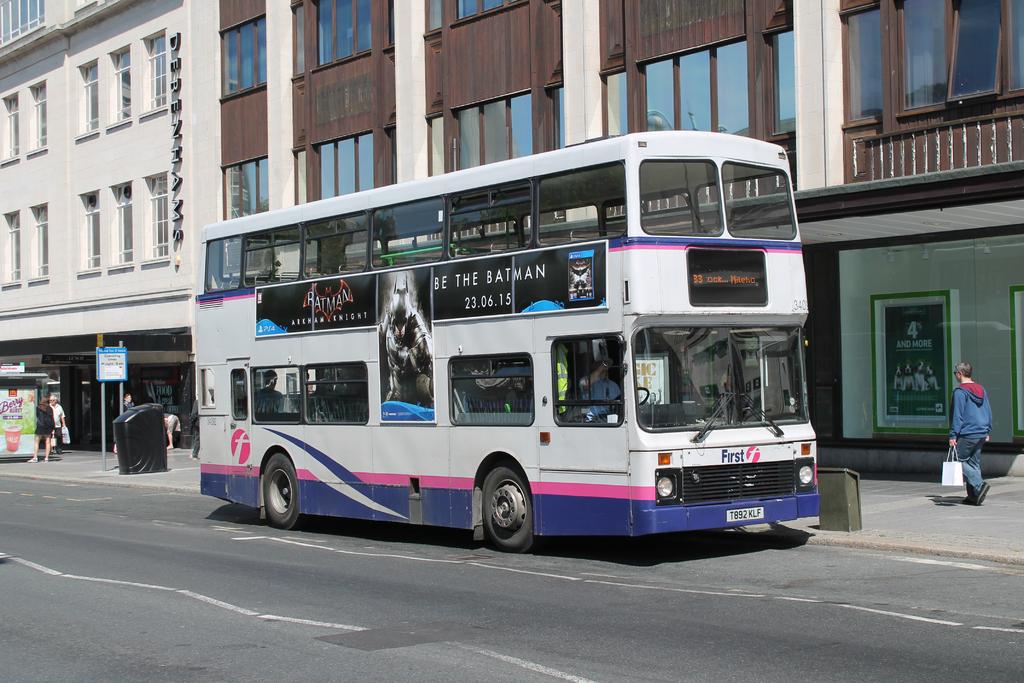What does the front of this bus say?
Offer a terse response. First. 